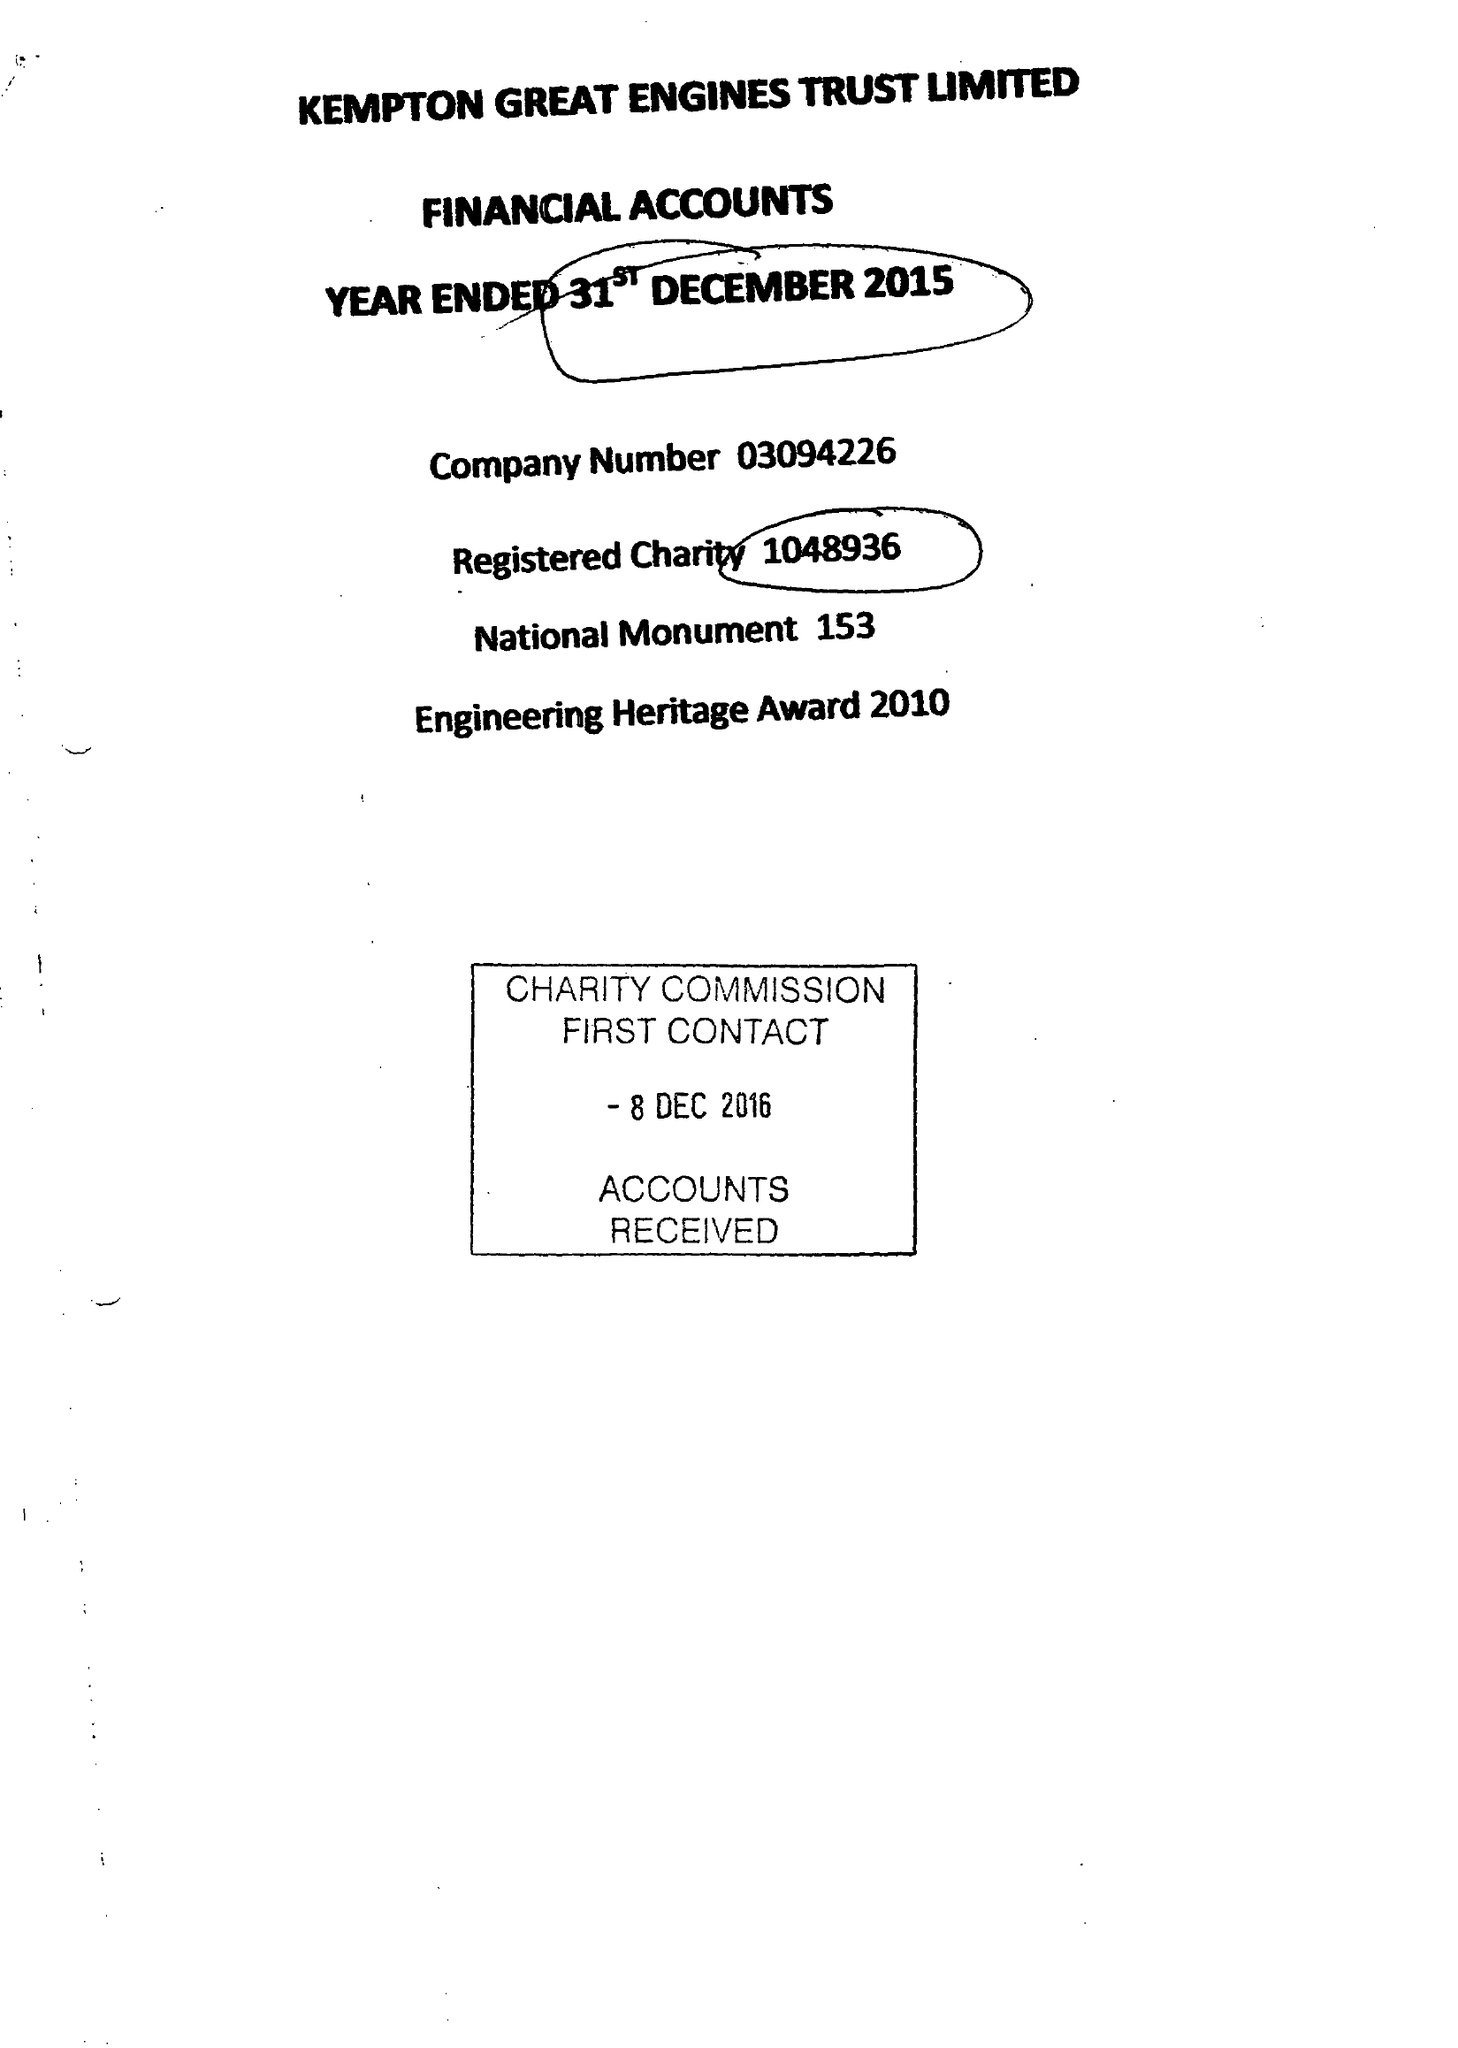What is the value for the address__street_line?
Answer the question using a single word or phrase. SNAKEY LANE 